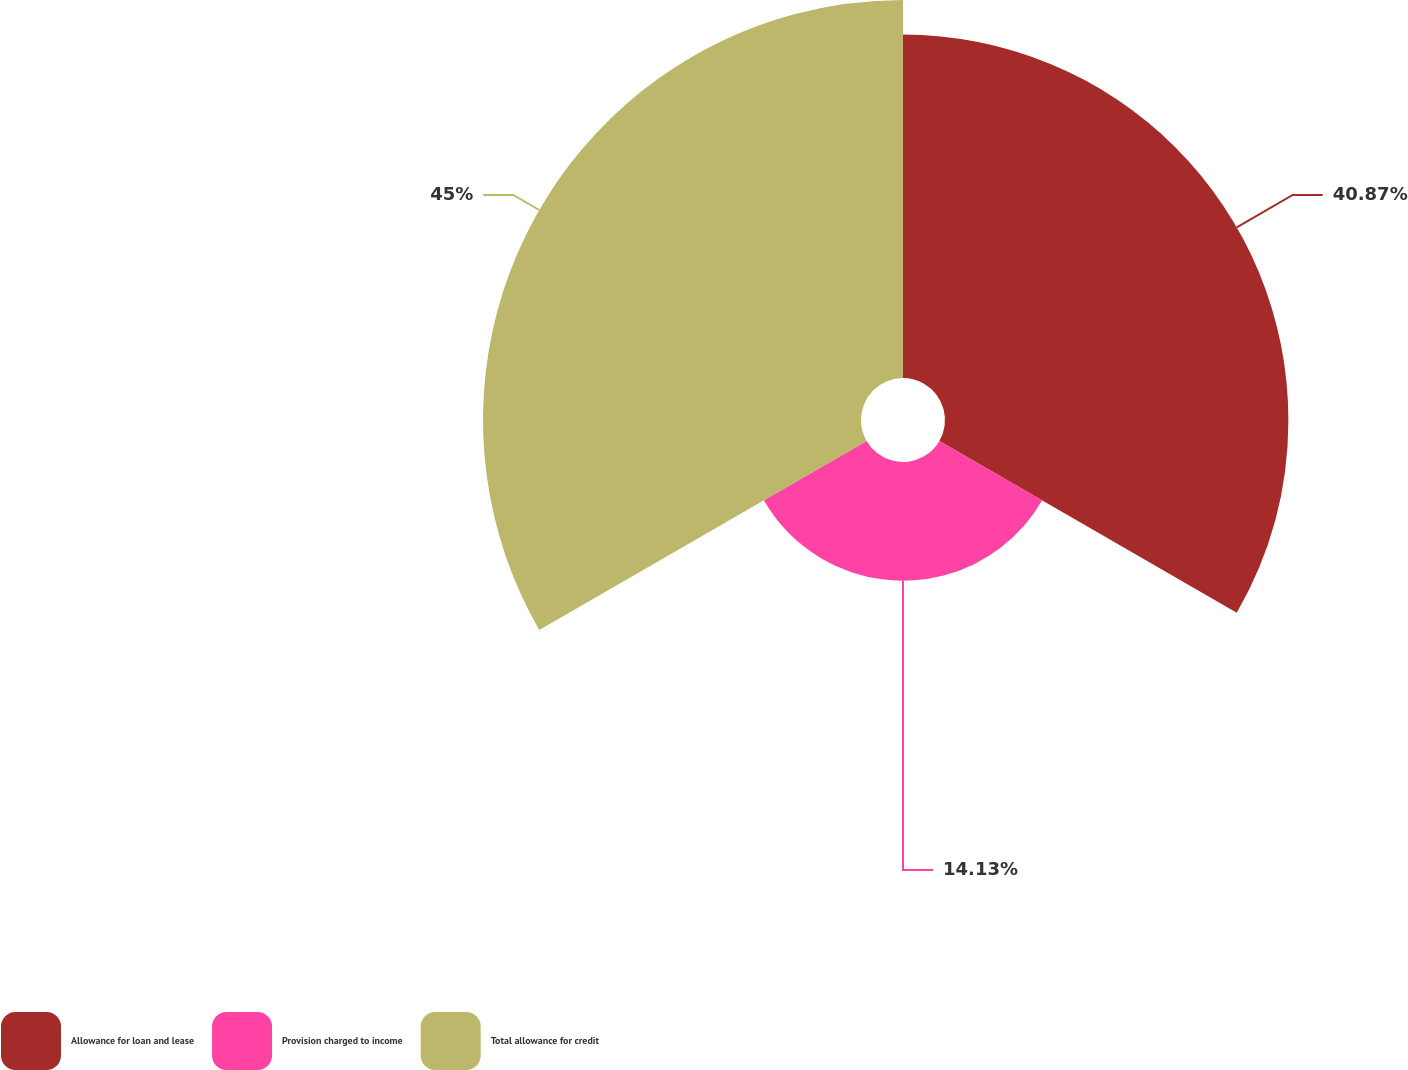Convert chart to OTSL. <chart><loc_0><loc_0><loc_500><loc_500><pie_chart><fcel>Allowance for loan and lease<fcel>Provision charged to income<fcel>Total allowance for credit<nl><fcel>40.87%<fcel>14.13%<fcel>44.99%<nl></chart> 